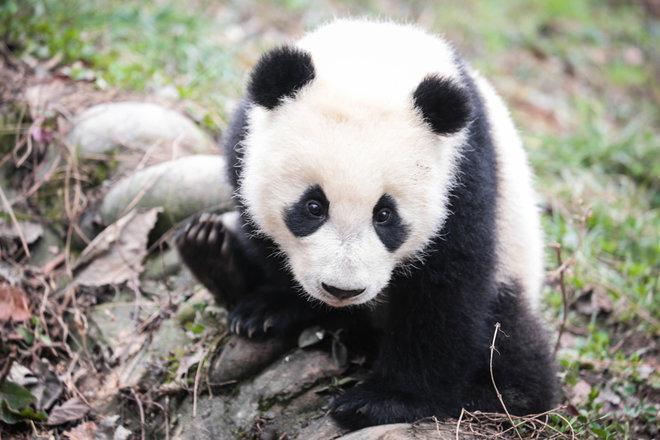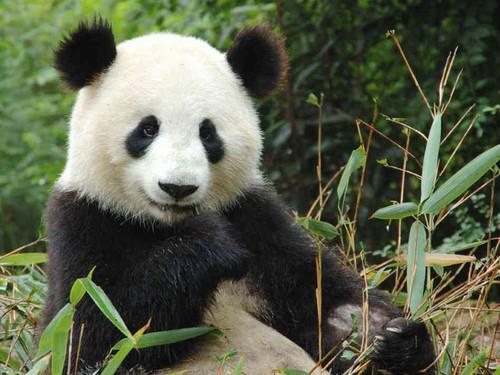The first image is the image on the left, the second image is the image on the right. Analyze the images presented: Is the assertion "One image shows a panda at play." valid? Answer yes or no. No. 